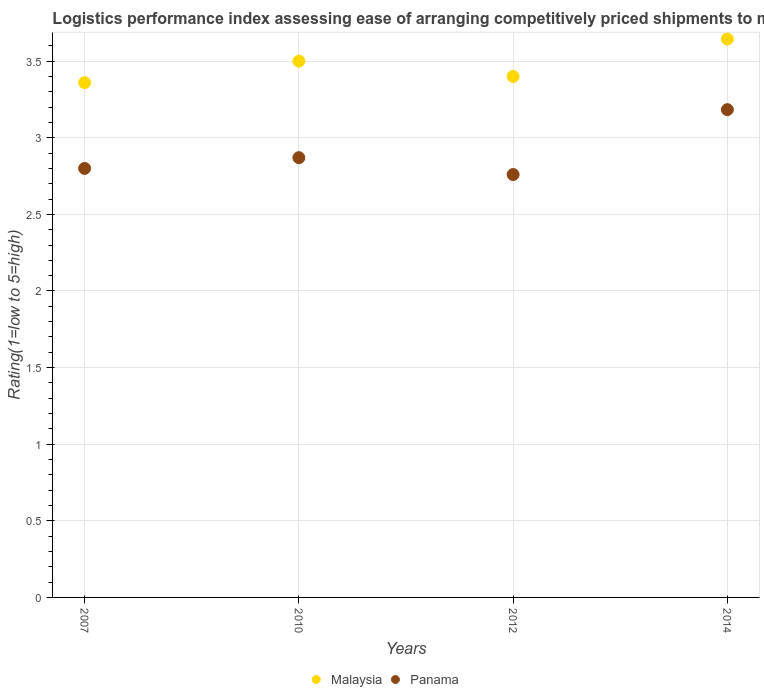How many different coloured dotlines are there?
Provide a succinct answer. 2. Is the number of dotlines equal to the number of legend labels?
Provide a short and direct response. Yes. What is the Logistic performance index in Malaysia in 2014?
Your response must be concise. 3.64. Across all years, what is the maximum Logistic performance index in Panama?
Make the answer very short. 3.18. Across all years, what is the minimum Logistic performance index in Malaysia?
Provide a short and direct response. 3.36. In which year was the Logistic performance index in Malaysia maximum?
Provide a succinct answer. 2014. What is the total Logistic performance index in Panama in the graph?
Your answer should be compact. 11.61. What is the difference between the Logistic performance index in Malaysia in 2010 and that in 2012?
Make the answer very short. 0.1. What is the difference between the Logistic performance index in Malaysia in 2014 and the Logistic performance index in Panama in 2007?
Make the answer very short. 0.84. What is the average Logistic performance index in Malaysia per year?
Ensure brevity in your answer.  3.48. In the year 2010, what is the difference between the Logistic performance index in Malaysia and Logistic performance index in Panama?
Your response must be concise. 0.63. What is the ratio of the Logistic performance index in Panama in 2007 to that in 2012?
Provide a short and direct response. 1.01. Is the difference between the Logistic performance index in Malaysia in 2007 and 2010 greater than the difference between the Logistic performance index in Panama in 2007 and 2010?
Keep it short and to the point. No. What is the difference between the highest and the second highest Logistic performance index in Panama?
Provide a short and direct response. 0.31. What is the difference between the highest and the lowest Logistic performance index in Malaysia?
Offer a terse response. 0.28. In how many years, is the Logistic performance index in Panama greater than the average Logistic performance index in Panama taken over all years?
Keep it short and to the point. 1. Does the Logistic performance index in Malaysia monotonically increase over the years?
Ensure brevity in your answer.  No. Is the Logistic performance index in Panama strictly less than the Logistic performance index in Malaysia over the years?
Offer a terse response. Yes. How many dotlines are there?
Offer a very short reply. 2. What is the difference between two consecutive major ticks on the Y-axis?
Keep it short and to the point. 0.5. What is the title of the graph?
Your answer should be very brief. Logistics performance index assessing ease of arranging competitively priced shipments to markets. Does "Japan" appear as one of the legend labels in the graph?
Offer a terse response. No. What is the label or title of the X-axis?
Your answer should be very brief. Years. What is the label or title of the Y-axis?
Your answer should be very brief. Rating(1=low to 5=high). What is the Rating(1=low to 5=high) of Malaysia in 2007?
Give a very brief answer. 3.36. What is the Rating(1=low to 5=high) in Panama in 2010?
Make the answer very short. 2.87. What is the Rating(1=low to 5=high) of Panama in 2012?
Give a very brief answer. 2.76. What is the Rating(1=low to 5=high) of Malaysia in 2014?
Offer a very short reply. 3.64. What is the Rating(1=low to 5=high) in Panama in 2014?
Keep it short and to the point. 3.18. Across all years, what is the maximum Rating(1=low to 5=high) of Malaysia?
Offer a very short reply. 3.64. Across all years, what is the maximum Rating(1=low to 5=high) in Panama?
Your response must be concise. 3.18. Across all years, what is the minimum Rating(1=low to 5=high) of Malaysia?
Your response must be concise. 3.36. Across all years, what is the minimum Rating(1=low to 5=high) in Panama?
Provide a short and direct response. 2.76. What is the total Rating(1=low to 5=high) in Malaysia in the graph?
Make the answer very short. 13.9. What is the total Rating(1=low to 5=high) of Panama in the graph?
Make the answer very short. 11.61. What is the difference between the Rating(1=low to 5=high) in Malaysia in 2007 and that in 2010?
Your answer should be compact. -0.14. What is the difference between the Rating(1=low to 5=high) of Panama in 2007 and that in 2010?
Your response must be concise. -0.07. What is the difference between the Rating(1=low to 5=high) in Malaysia in 2007 and that in 2012?
Give a very brief answer. -0.04. What is the difference between the Rating(1=low to 5=high) in Panama in 2007 and that in 2012?
Provide a succinct answer. 0.04. What is the difference between the Rating(1=low to 5=high) of Malaysia in 2007 and that in 2014?
Your answer should be very brief. -0.28. What is the difference between the Rating(1=low to 5=high) of Panama in 2007 and that in 2014?
Ensure brevity in your answer.  -0.38. What is the difference between the Rating(1=low to 5=high) of Panama in 2010 and that in 2012?
Your answer should be compact. 0.11. What is the difference between the Rating(1=low to 5=high) of Malaysia in 2010 and that in 2014?
Ensure brevity in your answer.  -0.14. What is the difference between the Rating(1=low to 5=high) of Panama in 2010 and that in 2014?
Provide a succinct answer. -0.31. What is the difference between the Rating(1=low to 5=high) in Malaysia in 2012 and that in 2014?
Make the answer very short. -0.24. What is the difference between the Rating(1=low to 5=high) of Panama in 2012 and that in 2014?
Keep it short and to the point. -0.42. What is the difference between the Rating(1=low to 5=high) of Malaysia in 2007 and the Rating(1=low to 5=high) of Panama in 2010?
Keep it short and to the point. 0.49. What is the difference between the Rating(1=low to 5=high) of Malaysia in 2007 and the Rating(1=low to 5=high) of Panama in 2012?
Ensure brevity in your answer.  0.6. What is the difference between the Rating(1=low to 5=high) of Malaysia in 2007 and the Rating(1=low to 5=high) of Panama in 2014?
Provide a short and direct response. 0.18. What is the difference between the Rating(1=low to 5=high) in Malaysia in 2010 and the Rating(1=low to 5=high) in Panama in 2012?
Keep it short and to the point. 0.74. What is the difference between the Rating(1=low to 5=high) of Malaysia in 2010 and the Rating(1=low to 5=high) of Panama in 2014?
Offer a very short reply. 0.32. What is the difference between the Rating(1=low to 5=high) in Malaysia in 2012 and the Rating(1=low to 5=high) in Panama in 2014?
Provide a succinct answer. 0.22. What is the average Rating(1=low to 5=high) of Malaysia per year?
Give a very brief answer. 3.48. What is the average Rating(1=low to 5=high) in Panama per year?
Make the answer very short. 2.9. In the year 2007, what is the difference between the Rating(1=low to 5=high) of Malaysia and Rating(1=low to 5=high) of Panama?
Make the answer very short. 0.56. In the year 2010, what is the difference between the Rating(1=low to 5=high) of Malaysia and Rating(1=low to 5=high) of Panama?
Your answer should be compact. 0.63. In the year 2012, what is the difference between the Rating(1=low to 5=high) of Malaysia and Rating(1=low to 5=high) of Panama?
Provide a succinct answer. 0.64. In the year 2014, what is the difference between the Rating(1=low to 5=high) of Malaysia and Rating(1=low to 5=high) of Panama?
Offer a terse response. 0.46. What is the ratio of the Rating(1=low to 5=high) in Malaysia in 2007 to that in 2010?
Provide a short and direct response. 0.96. What is the ratio of the Rating(1=low to 5=high) of Panama in 2007 to that in 2010?
Provide a succinct answer. 0.98. What is the ratio of the Rating(1=low to 5=high) in Malaysia in 2007 to that in 2012?
Give a very brief answer. 0.99. What is the ratio of the Rating(1=low to 5=high) in Panama in 2007 to that in 2012?
Provide a succinct answer. 1.01. What is the ratio of the Rating(1=low to 5=high) in Malaysia in 2007 to that in 2014?
Give a very brief answer. 0.92. What is the ratio of the Rating(1=low to 5=high) of Panama in 2007 to that in 2014?
Provide a succinct answer. 0.88. What is the ratio of the Rating(1=low to 5=high) of Malaysia in 2010 to that in 2012?
Keep it short and to the point. 1.03. What is the ratio of the Rating(1=low to 5=high) of Panama in 2010 to that in 2012?
Your response must be concise. 1.04. What is the ratio of the Rating(1=low to 5=high) of Malaysia in 2010 to that in 2014?
Your response must be concise. 0.96. What is the ratio of the Rating(1=low to 5=high) in Panama in 2010 to that in 2014?
Your response must be concise. 0.9. What is the ratio of the Rating(1=low to 5=high) of Malaysia in 2012 to that in 2014?
Give a very brief answer. 0.93. What is the ratio of the Rating(1=low to 5=high) of Panama in 2012 to that in 2014?
Offer a very short reply. 0.87. What is the difference between the highest and the second highest Rating(1=low to 5=high) in Malaysia?
Your answer should be compact. 0.14. What is the difference between the highest and the second highest Rating(1=low to 5=high) of Panama?
Provide a short and direct response. 0.31. What is the difference between the highest and the lowest Rating(1=low to 5=high) in Malaysia?
Provide a short and direct response. 0.28. What is the difference between the highest and the lowest Rating(1=low to 5=high) of Panama?
Keep it short and to the point. 0.42. 